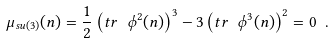Convert formula to latex. <formula><loc_0><loc_0><loc_500><loc_500>\mu _ { s u ( 3 ) } ( n ) = \frac { 1 } { 2 } \left ( t r \ \phi ^ { 2 } ( n ) \right ) ^ { 3 } - 3 \left ( t r \ \phi ^ { 3 } ( n ) \right ) ^ { 2 } = 0 \ .</formula> 